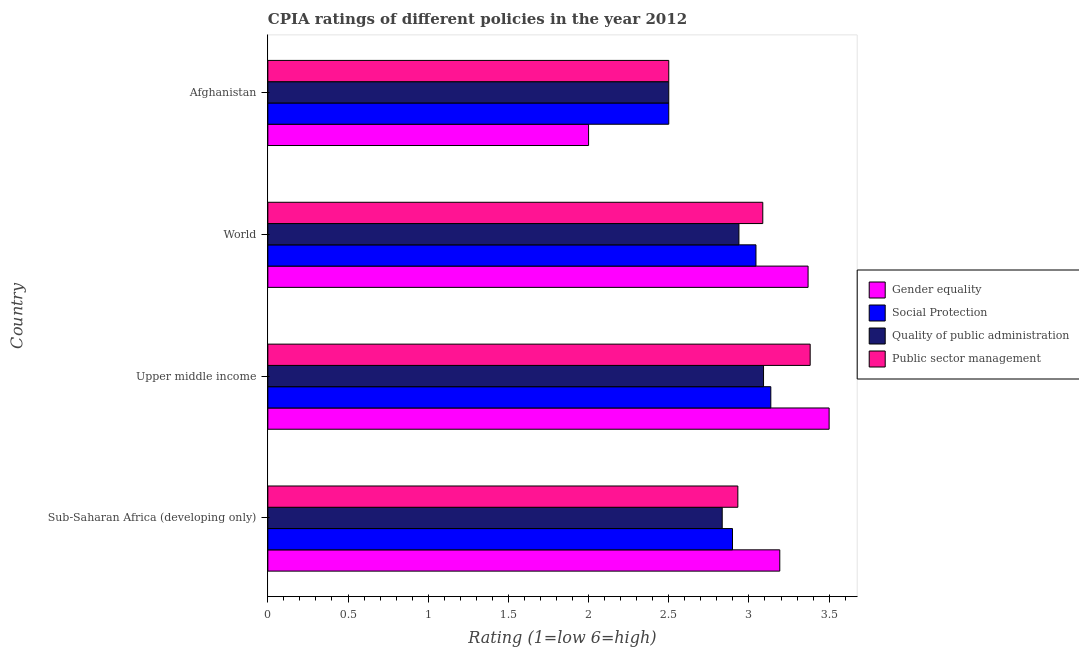How many different coloured bars are there?
Your answer should be compact. 4. Are the number of bars per tick equal to the number of legend labels?
Offer a terse response. Yes. Are the number of bars on each tick of the Y-axis equal?
Your answer should be compact. Yes. How many bars are there on the 4th tick from the top?
Keep it short and to the point. 4. How many bars are there on the 1st tick from the bottom?
Offer a very short reply. 4. What is the cpia rating of gender equality in Sub-Saharan Africa (developing only)?
Your response must be concise. 3.19. Across all countries, what is the minimum cpia rating of quality of public administration?
Provide a succinct answer. 2.5. In which country was the cpia rating of public sector management maximum?
Offer a very short reply. Upper middle income. In which country was the cpia rating of quality of public administration minimum?
Offer a terse response. Afghanistan. What is the total cpia rating of gender equality in the graph?
Provide a succinct answer. 12.06. What is the difference between the cpia rating of social protection in Afghanistan and that in Sub-Saharan Africa (developing only)?
Offer a terse response. -0.4. What is the difference between the cpia rating of social protection in Sub-Saharan Africa (developing only) and the cpia rating of quality of public administration in Upper middle income?
Give a very brief answer. -0.19. What is the average cpia rating of public sector management per country?
Provide a short and direct response. 2.98. What is the difference between the cpia rating of gender equality and cpia rating of social protection in Sub-Saharan Africa (developing only)?
Provide a succinct answer. 0.29. In how many countries, is the cpia rating of quality of public administration greater than 1.2 ?
Make the answer very short. 4. What is the ratio of the cpia rating of quality of public administration in Afghanistan to that in Upper middle income?
Offer a terse response. 0.81. Is the cpia rating of social protection in Afghanistan less than that in World?
Provide a succinct answer. Yes. Is the difference between the cpia rating of social protection in Afghanistan and World greater than the difference between the cpia rating of gender equality in Afghanistan and World?
Offer a very short reply. Yes. What is the difference between the highest and the second highest cpia rating of public sector management?
Keep it short and to the point. 0.3. What is the difference between the highest and the lowest cpia rating of gender equality?
Provide a succinct answer. 1.5. In how many countries, is the cpia rating of gender equality greater than the average cpia rating of gender equality taken over all countries?
Give a very brief answer. 3. What does the 2nd bar from the top in Upper middle income represents?
Keep it short and to the point. Quality of public administration. What does the 3rd bar from the bottom in Afghanistan represents?
Your answer should be compact. Quality of public administration. Are all the bars in the graph horizontal?
Your answer should be compact. Yes. Are the values on the major ticks of X-axis written in scientific E-notation?
Offer a very short reply. No. Does the graph contain any zero values?
Offer a terse response. No. Does the graph contain grids?
Your answer should be compact. No. Where does the legend appear in the graph?
Keep it short and to the point. Center right. How many legend labels are there?
Give a very brief answer. 4. How are the legend labels stacked?
Make the answer very short. Vertical. What is the title of the graph?
Your answer should be compact. CPIA ratings of different policies in the year 2012. Does "Interest Payments" appear as one of the legend labels in the graph?
Offer a very short reply. No. What is the Rating (1=low 6=high) of Gender equality in Sub-Saharan Africa (developing only)?
Give a very brief answer. 3.19. What is the Rating (1=low 6=high) of Social Protection in Sub-Saharan Africa (developing only)?
Keep it short and to the point. 2.9. What is the Rating (1=low 6=high) in Quality of public administration in Sub-Saharan Africa (developing only)?
Offer a very short reply. 2.83. What is the Rating (1=low 6=high) in Public sector management in Sub-Saharan Africa (developing only)?
Keep it short and to the point. 2.93. What is the Rating (1=low 6=high) of Social Protection in Upper middle income?
Keep it short and to the point. 3.14. What is the Rating (1=low 6=high) in Quality of public administration in Upper middle income?
Provide a succinct answer. 3.09. What is the Rating (1=low 6=high) of Public sector management in Upper middle income?
Keep it short and to the point. 3.38. What is the Rating (1=low 6=high) in Gender equality in World?
Keep it short and to the point. 3.37. What is the Rating (1=low 6=high) of Social Protection in World?
Provide a succinct answer. 3.04. What is the Rating (1=low 6=high) of Quality of public administration in World?
Provide a succinct answer. 2.94. What is the Rating (1=low 6=high) of Public sector management in World?
Make the answer very short. 3.09. What is the Rating (1=low 6=high) in Quality of public administration in Afghanistan?
Your answer should be very brief. 2.5. Across all countries, what is the maximum Rating (1=low 6=high) of Gender equality?
Your answer should be compact. 3.5. Across all countries, what is the maximum Rating (1=low 6=high) in Social Protection?
Offer a very short reply. 3.14. Across all countries, what is the maximum Rating (1=low 6=high) of Quality of public administration?
Make the answer very short. 3.09. Across all countries, what is the maximum Rating (1=low 6=high) in Public sector management?
Offer a very short reply. 3.38. Across all countries, what is the minimum Rating (1=low 6=high) of Public sector management?
Your answer should be compact. 2.5. What is the total Rating (1=low 6=high) in Gender equality in the graph?
Your answer should be compact. 12.06. What is the total Rating (1=low 6=high) in Social Protection in the graph?
Offer a very short reply. 11.58. What is the total Rating (1=low 6=high) of Quality of public administration in the graph?
Your response must be concise. 11.36. What is the total Rating (1=low 6=high) of Public sector management in the graph?
Keep it short and to the point. 11.9. What is the difference between the Rating (1=low 6=high) of Gender equality in Sub-Saharan Africa (developing only) and that in Upper middle income?
Offer a very short reply. -0.31. What is the difference between the Rating (1=low 6=high) in Social Protection in Sub-Saharan Africa (developing only) and that in Upper middle income?
Make the answer very short. -0.24. What is the difference between the Rating (1=low 6=high) of Quality of public administration in Sub-Saharan Africa (developing only) and that in Upper middle income?
Keep it short and to the point. -0.26. What is the difference between the Rating (1=low 6=high) of Public sector management in Sub-Saharan Africa (developing only) and that in Upper middle income?
Offer a terse response. -0.45. What is the difference between the Rating (1=low 6=high) in Gender equality in Sub-Saharan Africa (developing only) and that in World?
Provide a succinct answer. -0.18. What is the difference between the Rating (1=low 6=high) in Social Protection in Sub-Saharan Africa (developing only) and that in World?
Give a very brief answer. -0.15. What is the difference between the Rating (1=low 6=high) in Quality of public administration in Sub-Saharan Africa (developing only) and that in World?
Make the answer very short. -0.1. What is the difference between the Rating (1=low 6=high) in Public sector management in Sub-Saharan Africa (developing only) and that in World?
Keep it short and to the point. -0.16. What is the difference between the Rating (1=low 6=high) in Gender equality in Sub-Saharan Africa (developing only) and that in Afghanistan?
Your answer should be compact. 1.19. What is the difference between the Rating (1=low 6=high) in Social Protection in Sub-Saharan Africa (developing only) and that in Afghanistan?
Your answer should be very brief. 0.4. What is the difference between the Rating (1=low 6=high) of Quality of public administration in Sub-Saharan Africa (developing only) and that in Afghanistan?
Your answer should be very brief. 0.33. What is the difference between the Rating (1=low 6=high) of Public sector management in Sub-Saharan Africa (developing only) and that in Afghanistan?
Provide a short and direct response. 0.43. What is the difference between the Rating (1=low 6=high) of Gender equality in Upper middle income and that in World?
Offer a very short reply. 0.13. What is the difference between the Rating (1=low 6=high) in Social Protection in Upper middle income and that in World?
Make the answer very short. 0.09. What is the difference between the Rating (1=low 6=high) in Quality of public administration in Upper middle income and that in World?
Make the answer very short. 0.15. What is the difference between the Rating (1=low 6=high) of Public sector management in Upper middle income and that in World?
Offer a terse response. 0.3. What is the difference between the Rating (1=low 6=high) of Gender equality in Upper middle income and that in Afghanistan?
Your answer should be compact. 1.5. What is the difference between the Rating (1=low 6=high) in Social Protection in Upper middle income and that in Afghanistan?
Your response must be concise. 0.64. What is the difference between the Rating (1=low 6=high) of Quality of public administration in Upper middle income and that in Afghanistan?
Keep it short and to the point. 0.59. What is the difference between the Rating (1=low 6=high) of Public sector management in Upper middle income and that in Afghanistan?
Ensure brevity in your answer.  0.88. What is the difference between the Rating (1=low 6=high) in Gender equality in World and that in Afghanistan?
Your response must be concise. 1.37. What is the difference between the Rating (1=low 6=high) of Social Protection in World and that in Afghanistan?
Ensure brevity in your answer.  0.54. What is the difference between the Rating (1=low 6=high) in Quality of public administration in World and that in Afghanistan?
Make the answer very short. 0.44. What is the difference between the Rating (1=low 6=high) of Public sector management in World and that in Afghanistan?
Provide a short and direct response. 0.59. What is the difference between the Rating (1=low 6=high) in Gender equality in Sub-Saharan Africa (developing only) and the Rating (1=low 6=high) in Social Protection in Upper middle income?
Your response must be concise. 0.06. What is the difference between the Rating (1=low 6=high) in Gender equality in Sub-Saharan Africa (developing only) and the Rating (1=low 6=high) in Quality of public administration in Upper middle income?
Give a very brief answer. 0.1. What is the difference between the Rating (1=low 6=high) in Gender equality in Sub-Saharan Africa (developing only) and the Rating (1=low 6=high) in Public sector management in Upper middle income?
Give a very brief answer. -0.19. What is the difference between the Rating (1=low 6=high) in Social Protection in Sub-Saharan Africa (developing only) and the Rating (1=low 6=high) in Quality of public administration in Upper middle income?
Your answer should be compact. -0.19. What is the difference between the Rating (1=low 6=high) of Social Protection in Sub-Saharan Africa (developing only) and the Rating (1=low 6=high) of Public sector management in Upper middle income?
Your answer should be compact. -0.48. What is the difference between the Rating (1=low 6=high) in Quality of public administration in Sub-Saharan Africa (developing only) and the Rating (1=low 6=high) in Public sector management in Upper middle income?
Offer a terse response. -0.55. What is the difference between the Rating (1=low 6=high) in Gender equality in Sub-Saharan Africa (developing only) and the Rating (1=low 6=high) in Social Protection in World?
Your answer should be very brief. 0.15. What is the difference between the Rating (1=low 6=high) of Gender equality in Sub-Saharan Africa (developing only) and the Rating (1=low 6=high) of Quality of public administration in World?
Keep it short and to the point. 0.25. What is the difference between the Rating (1=low 6=high) in Gender equality in Sub-Saharan Africa (developing only) and the Rating (1=low 6=high) in Public sector management in World?
Ensure brevity in your answer.  0.11. What is the difference between the Rating (1=low 6=high) in Social Protection in Sub-Saharan Africa (developing only) and the Rating (1=low 6=high) in Quality of public administration in World?
Ensure brevity in your answer.  -0.04. What is the difference between the Rating (1=low 6=high) in Social Protection in Sub-Saharan Africa (developing only) and the Rating (1=low 6=high) in Public sector management in World?
Ensure brevity in your answer.  -0.19. What is the difference between the Rating (1=low 6=high) of Quality of public administration in Sub-Saharan Africa (developing only) and the Rating (1=low 6=high) of Public sector management in World?
Make the answer very short. -0.25. What is the difference between the Rating (1=low 6=high) of Gender equality in Sub-Saharan Africa (developing only) and the Rating (1=low 6=high) of Social Protection in Afghanistan?
Keep it short and to the point. 0.69. What is the difference between the Rating (1=low 6=high) of Gender equality in Sub-Saharan Africa (developing only) and the Rating (1=low 6=high) of Quality of public administration in Afghanistan?
Your answer should be very brief. 0.69. What is the difference between the Rating (1=low 6=high) of Gender equality in Sub-Saharan Africa (developing only) and the Rating (1=low 6=high) of Public sector management in Afghanistan?
Offer a very short reply. 0.69. What is the difference between the Rating (1=low 6=high) of Social Protection in Sub-Saharan Africa (developing only) and the Rating (1=low 6=high) of Quality of public administration in Afghanistan?
Make the answer very short. 0.4. What is the difference between the Rating (1=low 6=high) in Social Protection in Sub-Saharan Africa (developing only) and the Rating (1=low 6=high) in Public sector management in Afghanistan?
Keep it short and to the point. 0.4. What is the difference between the Rating (1=low 6=high) in Quality of public administration in Sub-Saharan Africa (developing only) and the Rating (1=low 6=high) in Public sector management in Afghanistan?
Your response must be concise. 0.33. What is the difference between the Rating (1=low 6=high) of Gender equality in Upper middle income and the Rating (1=low 6=high) of Social Protection in World?
Your answer should be compact. 0.46. What is the difference between the Rating (1=low 6=high) in Gender equality in Upper middle income and the Rating (1=low 6=high) in Quality of public administration in World?
Keep it short and to the point. 0.56. What is the difference between the Rating (1=low 6=high) in Gender equality in Upper middle income and the Rating (1=low 6=high) in Public sector management in World?
Provide a short and direct response. 0.41. What is the difference between the Rating (1=low 6=high) of Social Protection in Upper middle income and the Rating (1=low 6=high) of Quality of public administration in World?
Provide a succinct answer. 0.2. What is the difference between the Rating (1=low 6=high) of Social Protection in Upper middle income and the Rating (1=low 6=high) of Public sector management in World?
Provide a short and direct response. 0.05. What is the difference between the Rating (1=low 6=high) of Quality of public administration in Upper middle income and the Rating (1=low 6=high) of Public sector management in World?
Provide a short and direct response. 0. What is the difference between the Rating (1=low 6=high) of Gender equality in Upper middle income and the Rating (1=low 6=high) of Social Protection in Afghanistan?
Ensure brevity in your answer.  1. What is the difference between the Rating (1=low 6=high) in Social Protection in Upper middle income and the Rating (1=low 6=high) in Quality of public administration in Afghanistan?
Your answer should be compact. 0.64. What is the difference between the Rating (1=low 6=high) in Social Protection in Upper middle income and the Rating (1=low 6=high) in Public sector management in Afghanistan?
Keep it short and to the point. 0.64. What is the difference between the Rating (1=low 6=high) in Quality of public administration in Upper middle income and the Rating (1=low 6=high) in Public sector management in Afghanistan?
Offer a very short reply. 0.59. What is the difference between the Rating (1=low 6=high) in Gender equality in World and the Rating (1=low 6=high) in Social Protection in Afghanistan?
Your response must be concise. 0.87. What is the difference between the Rating (1=low 6=high) of Gender equality in World and the Rating (1=low 6=high) of Quality of public administration in Afghanistan?
Keep it short and to the point. 0.87. What is the difference between the Rating (1=low 6=high) of Gender equality in World and the Rating (1=low 6=high) of Public sector management in Afghanistan?
Your response must be concise. 0.87. What is the difference between the Rating (1=low 6=high) of Social Protection in World and the Rating (1=low 6=high) of Quality of public administration in Afghanistan?
Offer a terse response. 0.54. What is the difference between the Rating (1=low 6=high) in Social Protection in World and the Rating (1=low 6=high) in Public sector management in Afghanistan?
Provide a short and direct response. 0.54. What is the difference between the Rating (1=low 6=high) of Quality of public administration in World and the Rating (1=low 6=high) of Public sector management in Afghanistan?
Provide a succinct answer. 0.44. What is the average Rating (1=low 6=high) in Gender equality per country?
Your response must be concise. 3.02. What is the average Rating (1=low 6=high) in Social Protection per country?
Ensure brevity in your answer.  2.89. What is the average Rating (1=low 6=high) in Quality of public administration per country?
Make the answer very short. 2.84. What is the average Rating (1=low 6=high) of Public sector management per country?
Provide a short and direct response. 2.97. What is the difference between the Rating (1=low 6=high) in Gender equality and Rating (1=low 6=high) in Social Protection in Sub-Saharan Africa (developing only)?
Offer a very short reply. 0.29. What is the difference between the Rating (1=low 6=high) in Gender equality and Rating (1=low 6=high) in Quality of public administration in Sub-Saharan Africa (developing only)?
Give a very brief answer. 0.36. What is the difference between the Rating (1=low 6=high) of Gender equality and Rating (1=low 6=high) of Public sector management in Sub-Saharan Africa (developing only)?
Your response must be concise. 0.26. What is the difference between the Rating (1=low 6=high) in Social Protection and Rating (1=low 6=high) in Quality of public administration in Sub-Saharan Africa (developing only)?
Your response must be concise. 0.06. What is the difference between the Rating (1=low 6=high) in Social Protection and Rating (1=low 6=high) in Public sector management in Sub-Saharan Africa (developing only)?
Provide a short and direct response. -0.03. What is the difference between the Rating (1=low 6=high) in Quality of public administration and Rating (1=low 6=high) in Public sector management in Sub-Saharan Africa (developing only)?
Make the answer very short. -0.1. What is the difference between the Rating (1=low 6=high) of Gender equality and Rating (1=low 6=high) of Social Protection in Upper middle income?
Provide a short and direct response. 0.36. What is the difference between the Rating (1=low 6=high) of Gender equality and Rating (1=low 6=high) of Quality of public administration in Upper middle income?
Your response must be concise. 0.41. What is the difference between the Rating (1=low 6=high) of Gender equality and Rating (1=low 6=high) of Public sector management in Upper middle income?
Your response must be concise. 0.12. What is the difference between the Rating (1=low 6=high) of Social Protection and Rating (1=low 6=high) of Quality of public administration in Upper middle income?
Provide a short and direct response. 0.05. What is the difference between the Rating (1=low 6=high) in Social Protection and Rating (1=low 6=high) in Public sector management in Upper middle income?
Give a very brief answer. -0.25. What is the difference between the Rating (1=low 6=high) in Quality of public administration and Rating (1=low 6=high) in Public sector management in Upper middle income?
Ensure brevity in your answer.  -0.29. What is the difference between the Rating (1=low 6=high) of Gender equality and Rating (1=low 6=high) of Social Protection in World?
Offer a very short reply. 0.33. What is the difference between the Rating (1=low 6=high) of Gender equality and Rating (1=low 6=high) of Quality of public administration in World?
Your answer should be compact. 0.43. What is the difference between the Rating (1=low 6=high) in Gender equality and Rating (1=low 6=high) in Public sector management in World?
Ensure brevity in your answer.  0.28. What is the difference between the Rating (1=low 6=high) of Social Protection and Rating (1=low 6=high) of Quality of public administration in World?
Your answer should be compact. 0.11. What is the difference between the Rating (1=low 6=high) in Social Protection and Rating (1=low 6=high) in Public sector management in World?
Your answer should be very brief. -0.04. What is the difference between the Rating (1=low 6=high) of Quality of public administration and Rating (1=low 6=high) of Public sector management in World?
Your response must be concise. -0.15. What is the difference between the Rating (1=low 6=high) of Quality of public administration and Rating (1=low 6=high) of Public sector management in Afghanistan?
Provide a succinct answer. 0. What is the ratio of the Rating (1=low 6=high) in Gender equality in Sub-Saharan Africa (developing only) to that in Upper middle income?
Ensure brevity in your answer.  0.91. What is the ratio of the Rating (1=low 6=high) of Social Protection in Sub-Saharan Africa (developing only) to that in Upper middle income?
Offer a very short reply. 0.92. What is the ratio of the Rating (1=low 6=high) in Quality of public administration in Sub-Saharan Africa (developing only) to that in Upper middle income?
Ensure brevity in your answer.  0.92. What is the ratio of the Rating (1=low 6=high) in Public sector management in Sub-Saharan Africa (developing only) to that in Upper middle income?
Your answer should be compact. 0.87. What is the ratio of the Rating (1=low 6=high) in Gender equality in Sub-Saharan Africa (developing only) to that in World?
Provide a succinct answer. 0.95. What is the ratio of the Rating (1=low 6=high) in Social Protection in Sub-Saharan Africa (developing only) to that in World?
Offer a terse response. 0.95. What is the ratio of the Rating (1=low 6=high) in Quality of public administration in Sub-Saharan Africa (developing only) to that in World?
Your answer should be compact. 0.96. What is the ratio of the Rating (1=low 6=high) in Public sector management in Sub-Saharan Africa (developing only) to that in World?
Offer a terse response. 0.95. What is the ratio of the Rating (1=low 6=high) of Gender equality in Sub-Saharan Africa (developing only) to that in Afghanistan?
Your answer should be compact. 1.6. What is the ratio of the Rating (1=low 6=high) in Social Protection in Sub-Saharan Africa (developing only) to that in Afghanistan?
Give a very brief answer. 1.16. What is the ratio of the Rating (1=low 6=high) of Quality of public administration in Sub-Saharan Africa (developing only) to that in Afghanistan?
Offer a terse response. 1.13. What is the ratio of the Rating (1=low 6=high) of Public sector management in Sub-Saharan Africa (developing only) to that in Afghanistan?
Your answer should be very brief. 1.17. What is the ratio of the Rating (1=low 6=high) of Gender equality in Upper middle income to that in World?
Offer a very short reply. 1.04. What is the ratio of the Rating (1=low 6=high) of Social Protection in Upper middle income to that in World?
Keep it short and to the point. 1.03. What is the ratio of the Rating (1=low 6=high) of Quality of public administration in Upper middle income to that in World?
Keep it short and to the point. 1.05. What is the ratio of the Rating (1=low 6=high) of Public sector management in Upper middle income to that in World?
Provide a succinct answer. 1.1. What is the ratio of the Rating (1=low 6=high) of Gender equality in Upper middle income to that in Afghanistan?
Ensure brevity in your answer.  1.75. What is the ratio of the Rating (1=low 6=high) in Social Protection in Upper middle income to that in Afghanistan?
Offer a very short reply. 1.25. What is the ratio of the Rating (1=low 6=high) of Quality of public administration in Upper middle income to that in Afghanistan?
Offer a very short reply. 1.24. What is the ratio of the Rating (1=low 6=high) in Public sector management in Upper middle income to that in Afghanistan?
Make the answer very short. 1.35. What is the ratio of the Rating (1=low 6=high) of Gender equality in World to that in Afghanistan?
Provide a succinct answer. 1.68. What is the ratio of the Rating (1=low 6=high) of Social Protection in World to that in Afghanistan?
Offer a terse response. 1.22. What is the ratio of the Rating (1=low 6=high) of Quality of public administration in World to that in Afghanistan?
Give a very brief answer. 1.18. What is the ratio of the Rating (1=low 6=high) in Public sector management in World to that in Afghanistan?
Make the answer very short. 1.23. What is the difference between the highest and the second highest Rating (1=low 6=high) of Gender equality?
Make the answer very short. 0.13. What is the difference between the highest and the second highest Rating (1=low 6=high) of Social Protection?
Provide a short and direct response. 0.09. What is the difference between the highest and the second highest Rating (1=low 6=high) of Quality of public administration?
Provide a succinct answer. 0.15. What is the difference between the highest and the second highest Rating (1=low 6=high) in Public sector management?
Your answer should be compact. 0.3. What is the difference between the highest and the lowest Rating (1=low 6=high) in Social Protection?
Your response must be concise. 0.64. What is the difference between the highest and the lowest Rating (1=low 6=high) of Quality of public administration?
Make the answer very short. 0.59. What is the difference between the highest and the lowest Rating (1=low 6=high) in Public sector management?
Your answer should be very brief. 0.88. 